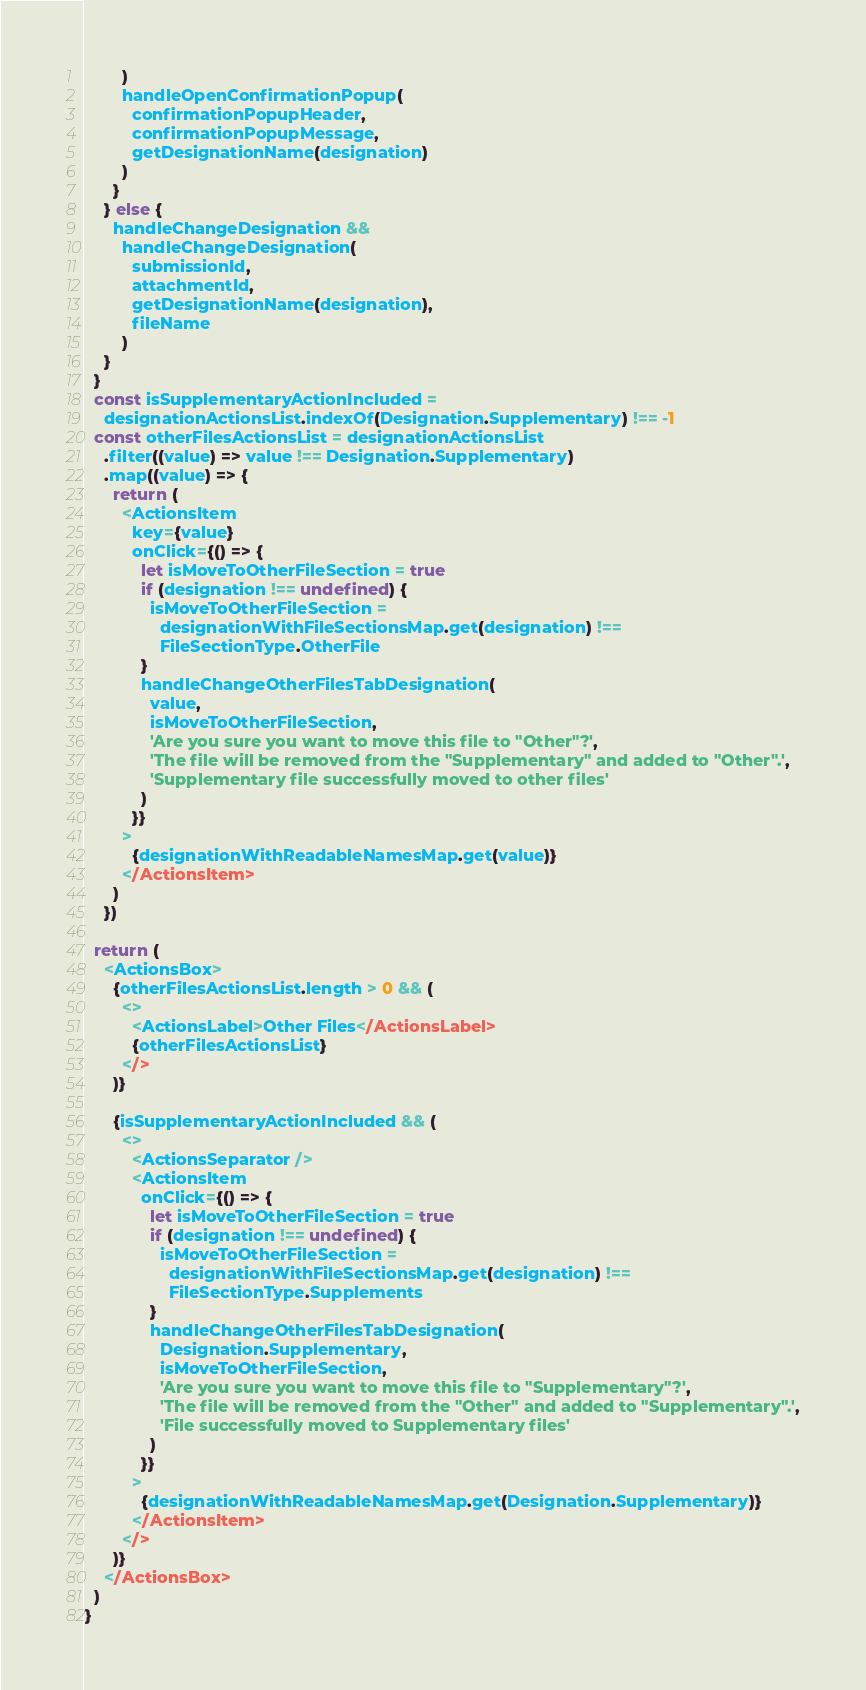<code> <loc_0><loc_0><loc_500><loc_500><_TypeScript_>        )
        handleOpenConfirmationPopup(
          confirmationPopupHeader,
          confirmationPopupMessage,
          getDesignationName(designation)
        )
      }
    } else {
      handleChangeDesignation &&
        handleChangeDesignation(
          submissionId,
          attachmentId,
          getDesignationName(designation),
          fileName
        )
    }
  }
  const isSupplementaryActionIncluded =
    designationActionsList.indexOf(Designation.Supplementary) !== -1
  const otherFilesActionsList = designationActionsList
    .filter((value) => value !== Designation.Supplementary)
    .map((value) => {
      return (
        <ActionsItem
          key={value}
          onClick={() => {
            let isMoveToOtherFileSection = true
            if (designation !== undefined) {
              isMoveToOtherFileSection =
                designationWithFileSectionsMap.get(designation) !==
                FileSectionType.OtherFile
            }
            handleChangeOtherFilesTabDesignation(
              value,
              isMoveToOtherFileSection,
              'Are you sure you want to move this file to "Other"?',
              'The file will be removed from the "Supplementary" and added to "Other".',
              'Supplementary file successfully moved to other files'
            )
          }}
        >
          {designationWithReadableNamesMap.get(value)}
        </ActionsItem>
      )
    })

  return (
    <ActionsBox>
      {otherFilesActionsList.length > 0 && (
        <>
          <ActionsLabel>Other Files</ActionsLabel>
          {otherFilesActionsList}
        </>
      )}

      {isSupplementaryActionIncluded && (
        <>
          <ActionsSeparator />
          <ActionsItem
            onClick={() => {
              let isMoveToOtherFileSection = true
              if (designation !== undefined) {
                isMoveToOtherFileSection =
                  designationWithFileSectionsMap.get(designation) !==
                  FileSectionType.Supplements
              }
              handleChangeOtherFilesTabDesignation(
                Designation.Supplementary,
                isMoveToOtherFileSection,
                'Are you sure you want to move this file to "Supplementary"?',
                'The file will be removed from the "Other" and added to "Supplementary".',
                'File successfully moved to Supplementary files'
              )
            }}
          >
            {designationWithReadableNamesMap.get(Designation.Supplementary)}
          </ActionsItem>
        </>
      )}
    </ActionsBox>
  )
}
</code> 